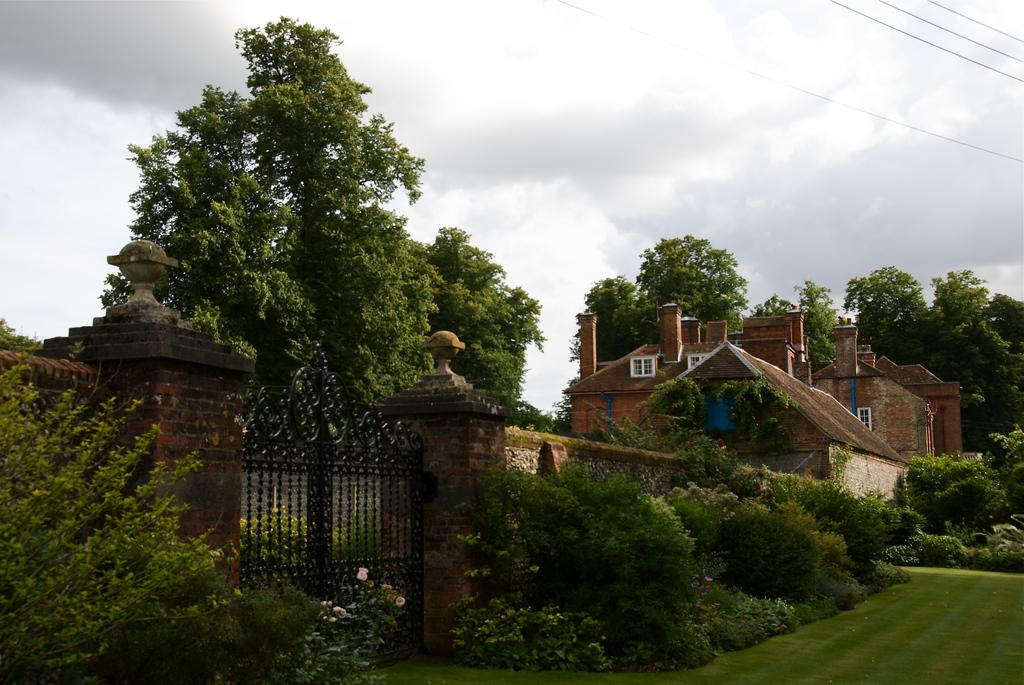What structure serves as a boundary in the image? There is a gate in the image that serves as a boundary. What can be found on the other side of the gate? Many trees and plants are outside the boundary. What type of structure is present in the image? There is a building in the image. What can be seen in the background of the image? Trees are visible in the background of the image. How would you describe the weather in the image? The sky is cloudy in the image. What type of feast is being prepared in the image? There is no indication of a feast being prepared in the image. What color is the hat worn by the person in the image? There is no person wearing a hat in the image. 